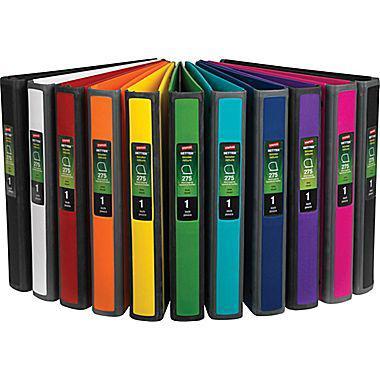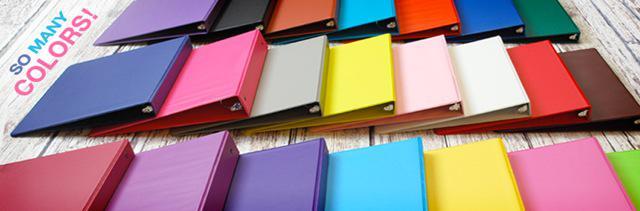The first image is the image on the left, the second image is the image on the right. Examine the images to the left and right. Is the description "there are no more than four binders in the image on the right" accurate? Answer yes or no. No. The first image is the image on the left, the second image is the image on the right. For the images shown, is this caption "An image shows multiple colored binders arranged to form a semi-circular arch." true? Answer yes or no. Yes. 